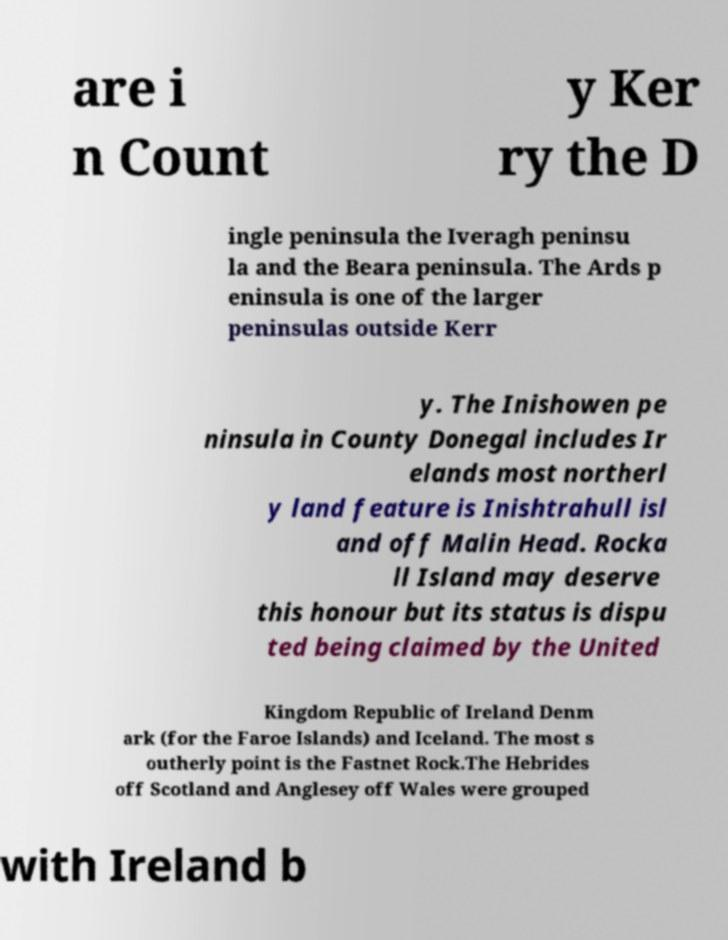Please identify and transcribe the text found in this image. are i n Count y Ker ry the D ingle peninsula the Iveragh peninsu la and the Beara peninsula. The Ards p eninsula is one of the larger peninsulas outside Kerr y. The Inishowen pe ninsula in County Donegal includes Ir elands most northerl y land feature is Inishtrahull isl and off Malin Head. Rocka ll Island may deserve this honour but its status is dispu ted being claimed by the United Kingdom Republic of Ireland Denm ark (for the Faroe Islands) and Iceland. The most s outherly point is the Fastnet Rock.The Hebrides off Scotland and Anglesey off Wales were grouped with Ireland b 